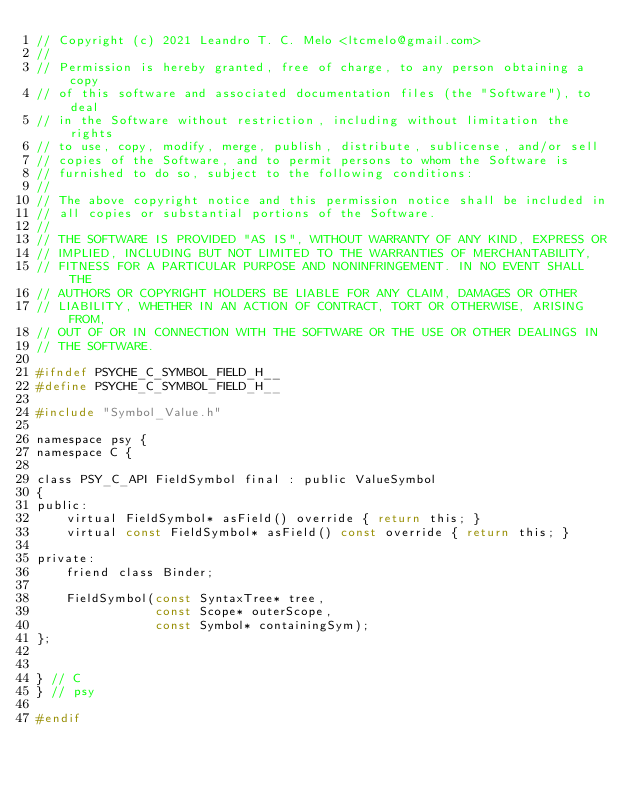Convert code to text. <code><loc_0><loc_0><loc_500><loc_500><_C_>// Copyright (c) 2021 Leandro T. C. Melo <ltcmelo@gmail.com>
//
// Permission is hereby granted, free of charge, to any person obtaining a copy
// of this software and associated documentation files (the "Software"), to deal
// in the Software without restriction, including without limitation the rights
// to use, copy, modify, merge, publish, distribute, sublicense, and/or sell
// copies of the Software, and to permit persons to whom the Software is
// furnished to do so, subject to the following conditions:
//
// The above copyright notice and this permission notice shall be included in
// all copies or substantial portions of the Software.
//
// THE SOFTWARE IS PROVIDED "AS IS", WITHOUT WARRANTY OF ANY KIND, EXPRESS OR
// IMPLIED, INCLUDING BUT NOT LIMITED TO THE WARRANTIES OF MERCHANTABILITY,
// FITNESS FOR A PARTICULAR PURPOSE AND NONINFRINGEMENT. IN NO EVENT SHALL THE
// AUTHORS OR COPYRIGHT HOLDERS BE LIABLE FOR ANY CLAIM, DAMAGES OR OTHER
// LIABILITY, WHETHER IN AN ACTION OF CONTRACT, TORT OR OTHERWISE, ARISING FROM,
// OUT OF OR IN CONNECTION WITH THE SOFTWARE OR THE USE OR OTHER DEALINGS IN
// THE SOFTWARE.

#ifndef PSYCHE_C_SYMBOL_FIELD_H__
#define PSYCHE_C_SYMBOL_FIELD_H__

#include "Symbol_Value.h"

namespace psy {
namespace C {

class PSY_C_API FieldSymbol final : public ValueSymbol
{
public:
    virtual FieldSymbol* asField() override { return this; }
    virtual const FieldSymbol* asField() const override { return this; }

private:
    friend class Binder;

    FieldSymbol(const SyntaxTree* tree,
                const Scope* outerScope,
                const Symbol* containingSym);
};


} // C
} // psy

#endif
</code> 